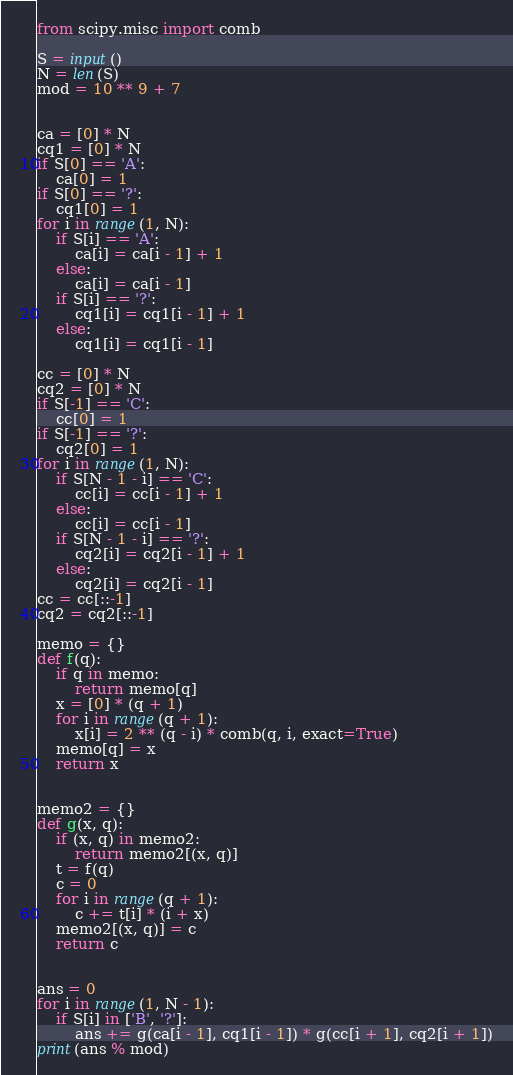<code> <loc_0><loc_0><loc_500><loc_500><_Python_>from scipy.misc import comb

S = input()
N = len(S)
mod = 10 ** 9 + 7


ca = [0] * N
cq1 = [0] * N
if S[0] == 'A':
    ca[0] = 1
if S[0] == '?':
    cq1[0] = 1
for i in range(1, N):
    if S[i] == 'A':
        ca[i] = ca[i - 1] + 1
    else:
        ca[i] = ca[i - 1]
    if S[i] == '?':
        cq1[i] = cq1[i - 1] + 1
    else:
        cq1[i] = cq1[i - 1]

cc = [0] * N
cq2 = [0] * N
if S[-1] == 'C':
    cc[0] = 1
if S[-1] == '?':
    cq2[0] = 1
for i in range(1, N):
    if S[N - 1 - i] == 'C':
        cc[i] = cc[i - 1] + 1
    else:
        cc[i] = cc[i - 1]
    if S[N - 1 - i] == '?':
        cq2[i] = cq2[i - 1] + 1
    else:
        cq2[i] = cq2[i - 1]
cc = cc[::-1]
cq2 = cq2[::-1]

memo = {}
def f(q):
    if q in memo:
        return memo[q]
    x = [0] * (q + 1)
    for i in range(q + 1):
        x[i] = 2 ** (q - i) * comb(q, i, exact=True)
    memo[q] = x
    return x


memo2 = {}
def g(x, q):
    if (x, q) in memo2:
        return memo2[(x, q)]
    t = f(q)
    c = 0
    for i in range(q + 1):
        c += t[i] * (i + x)
    memo2[(x, q)] = c
    return c


ans = 0
for i in range(1, N - 1):
    if S[i] in ['B', '?']:
        ans += g(ca[i - 1], cq1[i - 1]) * g(cc[i + 1], cq2[i + 1])
print(ans % mod)
</code> 